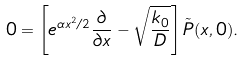Convert formula to latex. <formula><loc_0><loc_0><loc_500><loc_500>0 = \left [ e ^ { \alpha x ^ { 2 } / 2 } \frac { \partial } { \partial x } - \sqrt { \frac { k _ { 0 } } { D } } \right ] { \tilde { P } } ( x , 0 ) .</formula> 